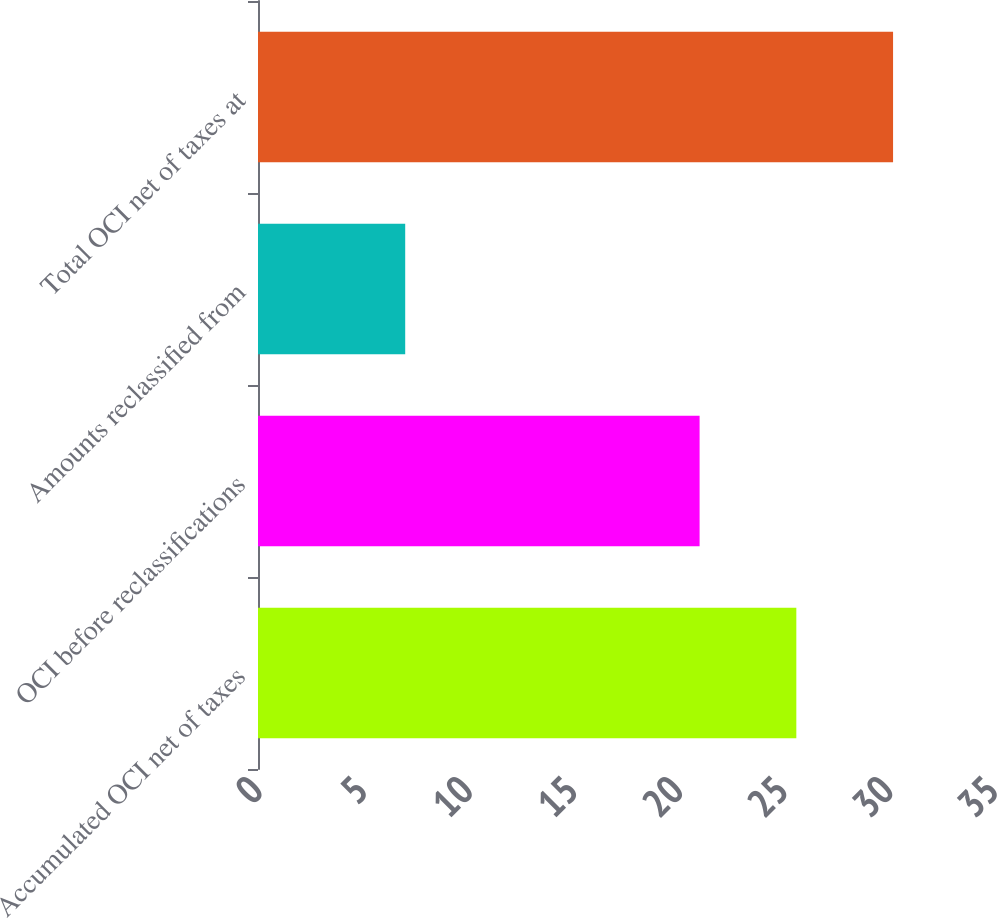<chart> <loc_0><loc_0><loc_500><loc_500><bar_chart><fcel>Accumulated OCI net of taxes<fcel>OCI before reclassifications<fcel>Amounts reclassified from<fcel>Total OCI net of taxes at<nl><fcel>25.6<fcel>21<fcel>7<fcel>30.2<nl></chart> 